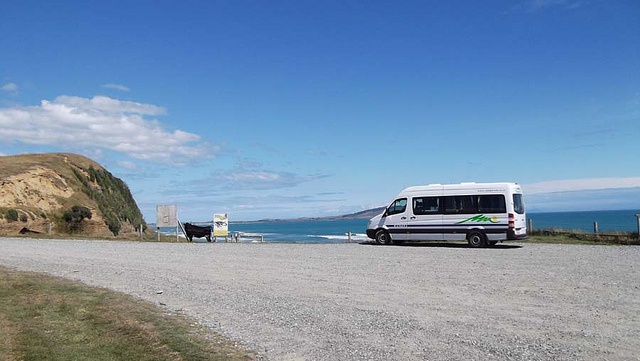Describe the objects in this image and their specific colors. I can see bus in blue, black, lavender, and darkgray tones and cow in blue, black, gray, and darkgray tones in this image. 